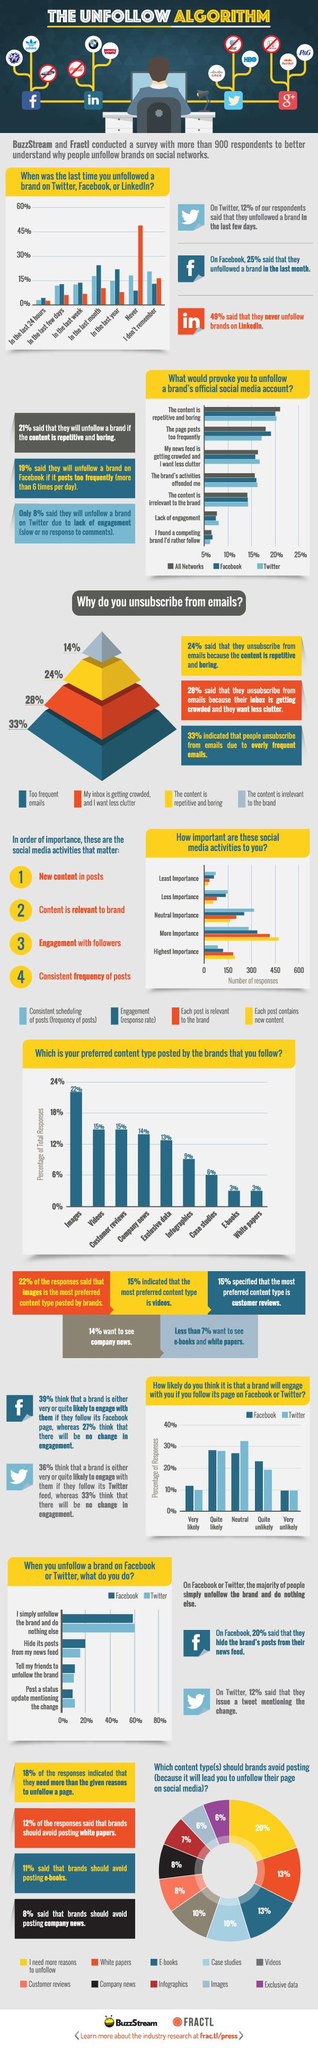Draw attention to some important aspects in this diagram. According to a survey of Facebook users, 20% said that they will unfollow a brand if the content is repetitive and boring. The third most preferred content type is company news. After unfollowing a brand on Twitter, 60% of users simply unfollow the brand and do nothing else. According to the survey, infographics is the content type that is preferred by 9% of respondents. The most common reason for unsubscribing from emails is due to receiving too many emails. 